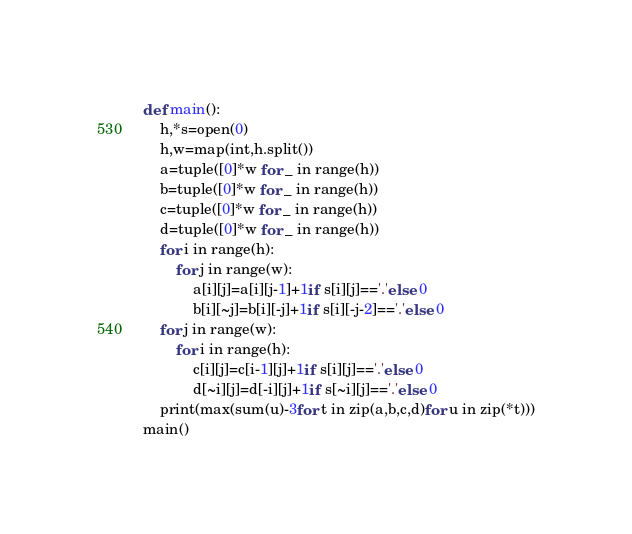Convert code to text. <code><loc_0><loc_0><loc_500><loc_500><_Python_>def main():
    h,*s=open(0)
    h,w=map(int,h.split())
    a=tuple([0]*w for _ in range(h))
    b=tuple([0]*w for _ in range(h))
    c=tuple([0]*w for _ in range(h))
    d=tuple([0]*w for _ in range(h))
    for i in range(h):
        for j in range(w):
            a[i][j]=a[i][j-1]+1if s[i][j]=='.'else 0
            b[i][~j]=b[i][-j]+1if s[i][-j-2]=='.'else 0
    for j in range(w):
        for i in range(h):
            c[i][j]=c[i-1][j]+1if s[i][j]=='.'else 0
            d[~i][j]=d[-i][j]+1if s[~i][j]=='.'else 0
    print(max(sum(u)-3for t in zip(a,b,c,d)for u in zip(*t)))
main()</code> 